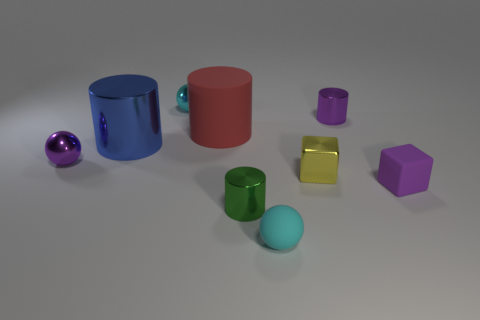Add 1 small gray shiny things. How many objects exist? 10 Subtract all cylinders. How many objects are left? 5 Add 4 green metal objects. How many green metal objects exist? 5 Subtract 1 cyan balls. How many objects are left? 8 Subtract all blue objects. Subtract all shiny cubes. How many objects are left? 7 Add 2 purple blocks. How many purple blocks are left? 3 